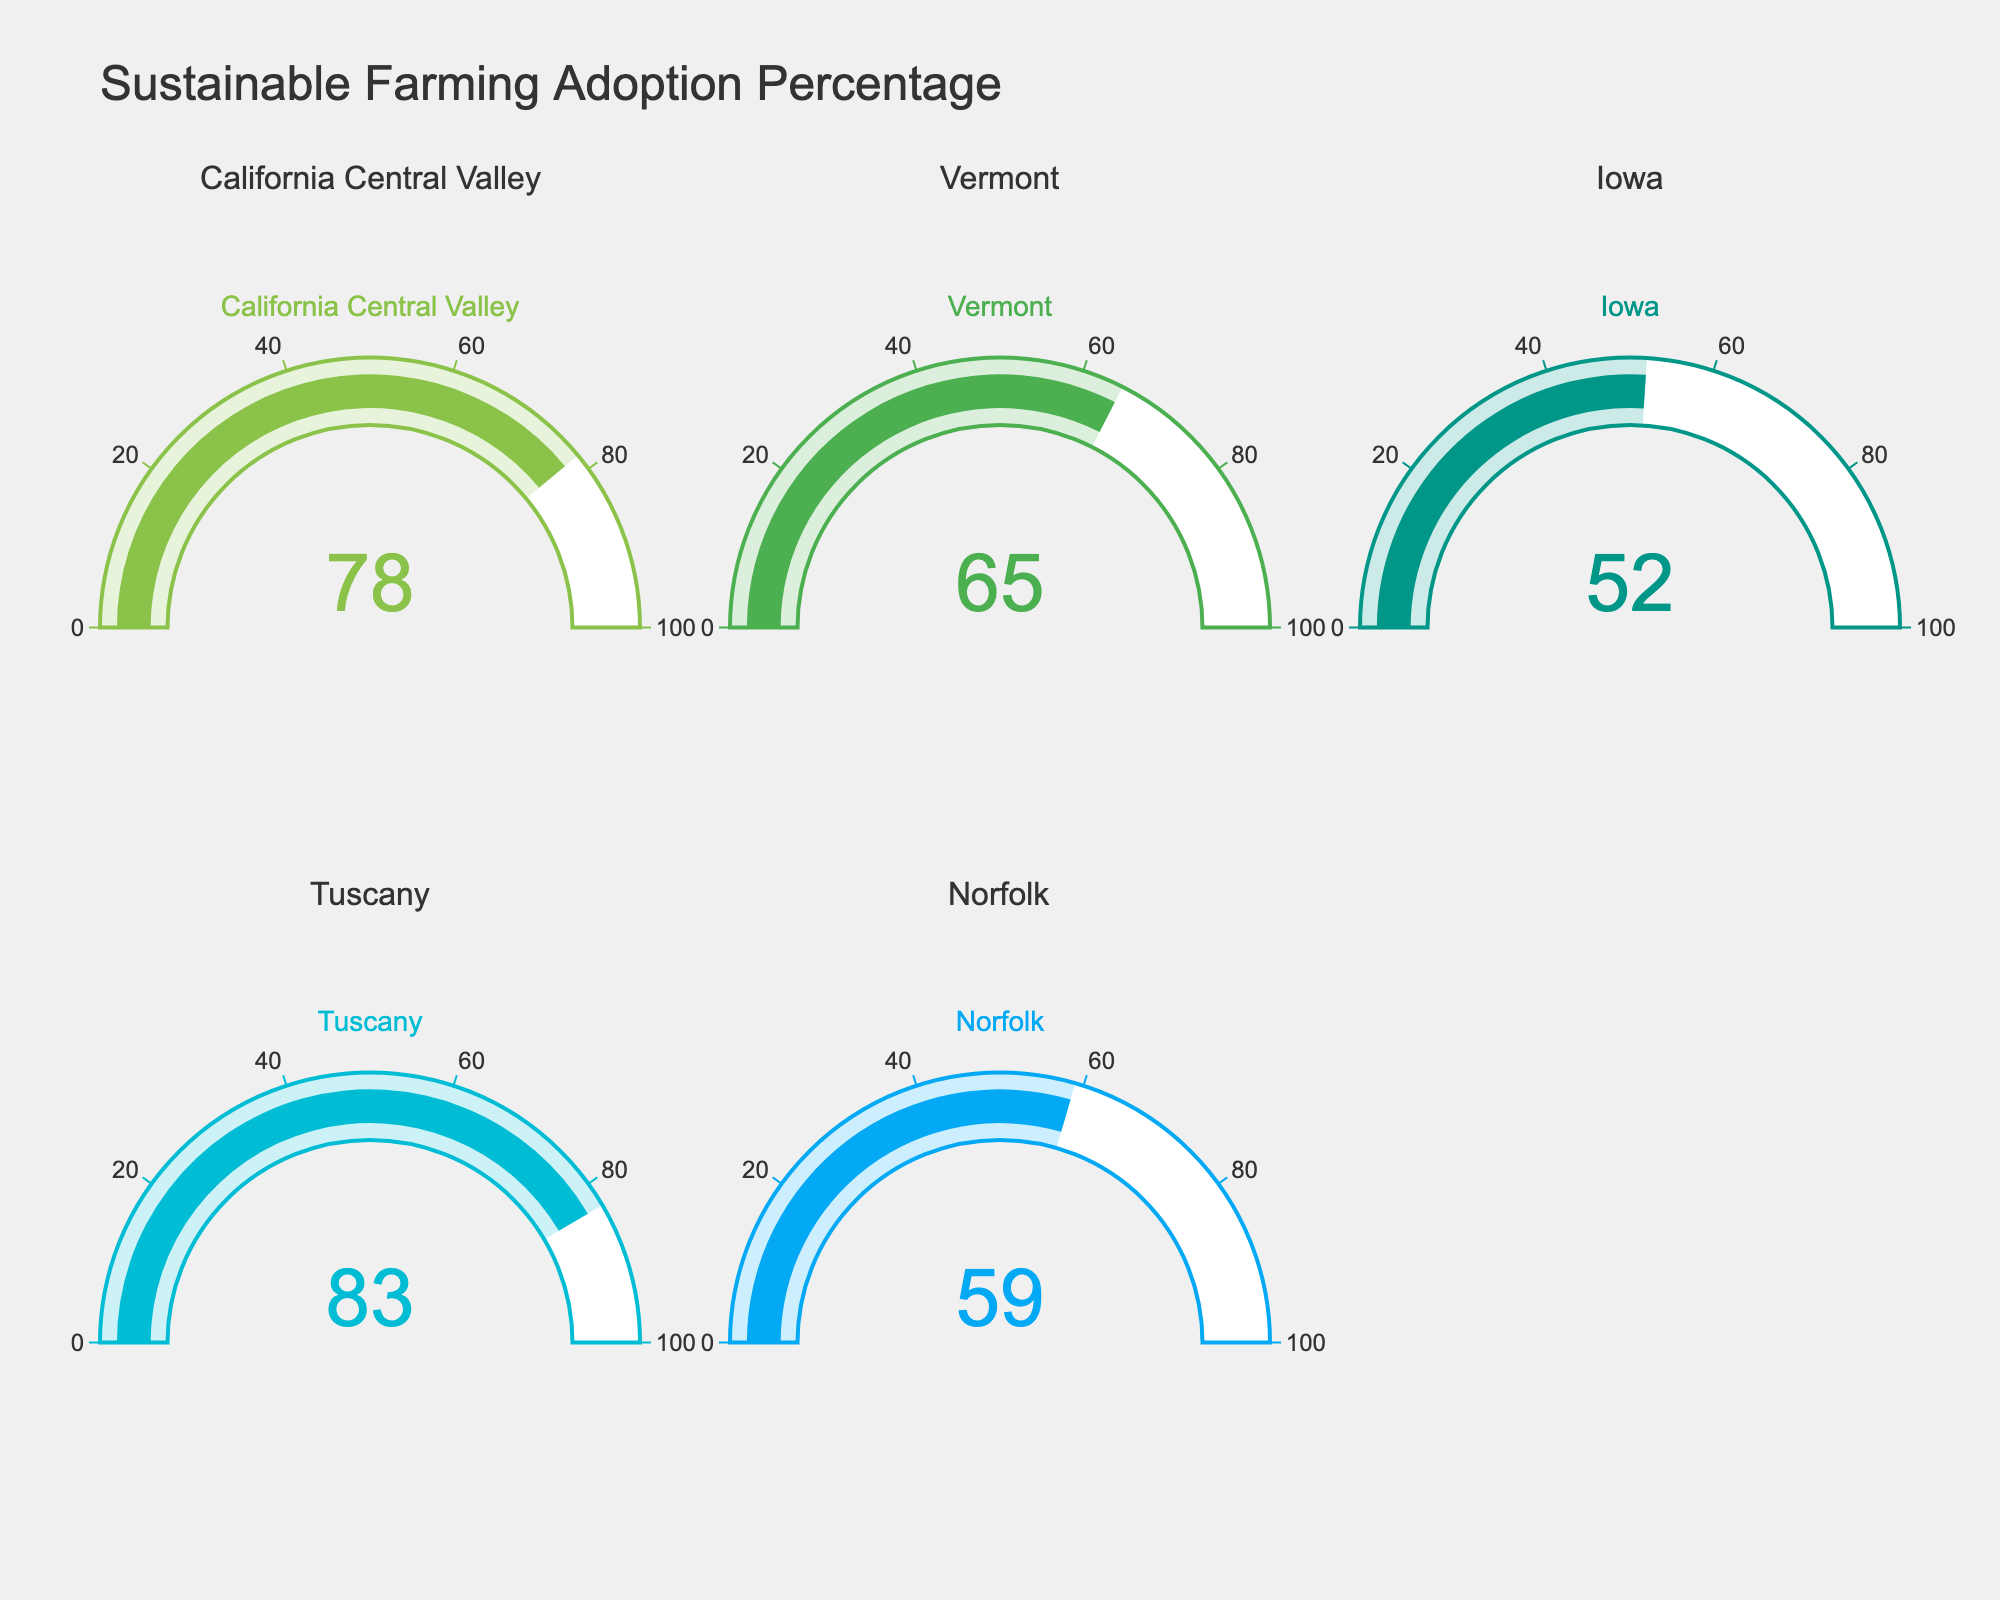What is the percentage of local farmers adopting sustainable farming techniques in Vermont? The gauge for Vermont shows a percentage of 65.
Answer: 65 Which region has the highest adoption percentage for sustainable farming techniques? Tuscany has the highest gauge value among all regions, indicating the highest percentage of adoption, which is 83.
Answer: Tuscany How much higher is the adoption percentage in California Central Valley compared to Iowa? The gauge in California Central Valley shows 78% while in Iowa it shows 52%. The difference is 78 - 52 = 26.
Answer: 26 What is the average adoption percentage for all the regions shown in the figure? Add the percentages from all regions (78 + 65 + 52 + 83 + 59) = 337, then divide by 5 (number of regions). 337 / 5 = 67.4
Answer: 67.4 Which regions have an adoption percentage lower than 60%? The regions with percentages below 60 are Iowa (52%) and Norfolk (59%).
Answer: Iowa, Norfolk Rank the regions from highest to lowest adoption percentage. The percentages are: Tuscany (83), California Central Valley (78), Vermont (65), Norfolk (59), Iowa (52).
Answer: Tuscany, California Central Valley, Vermont, Norfolk, Iowa What is the combined adoption percentage of Vermont and Norfolk? Add the percentages of Vermont and Norfolk: 65 + 59 = 124.
Answer: 124 Is the adoption percentage in Tuscan higher or lower than 80%? The gauge for Tuscany indicates an adoption percentage of 83, which is higher than 80%.
Answer: Higher How many regions have an adoption percentage greater than 70%? California Central Valley (78) and Tuscany (83) both have adoption percentages greater than 70%. That makes 2 regions.
Answer: 2 